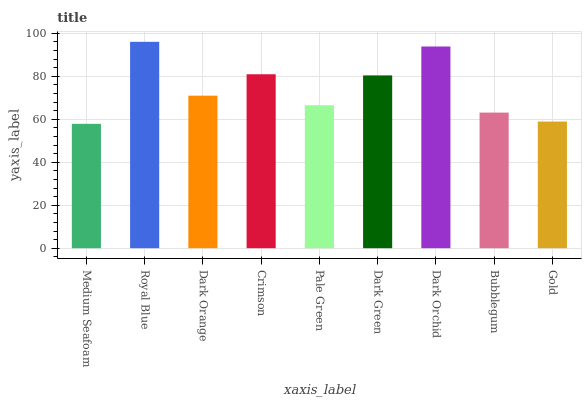Is Medium Seafoam the minimum?
Answer yes or no. Yes. Is Royal Blue the maximum?
Answer yes or no. Yes. Is Dark Orange the minimum?
Answer yes or no. No. Is Dark Orange the maximum?
Answer yes or no. No. Is Royal Blue greater than Dark Orange?
Answer yes or no. Yes. Is Dark Orange less than Royal Blue?
Answer yes or no. Yes. Is Dark Orange greater than Royal Blue?
Answer yes or no. No. Is Royal Blue less than Dark Orange?
Answer yes or no. No. Is Dark Orange the high median?
Answer yes or no. Yes. Is Dark Orange the low median?
Answer yes or no. Yes. Is Crimson the high median?
Answer yes or no. No. Is Pale Green the low median?
Answer yes or no. No. 